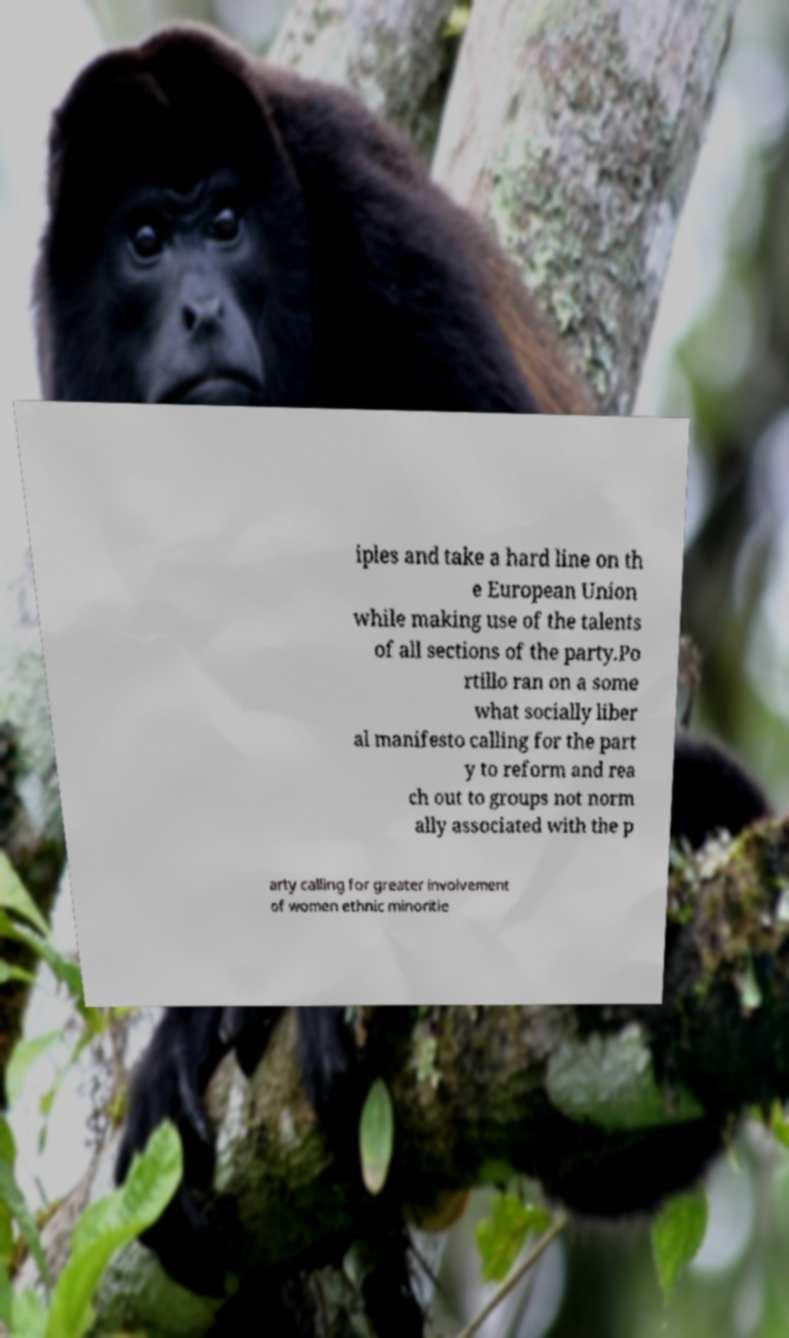Could you assist in decoding the text presented in this image and type it out clearly? iples and take a hard line on th e European Union while making use of the talents of all sections of the party.Po rtillo ran on a some what socially liber al manifesto calling for the part y to reform and rea ch out to groups not norm ally associated with the p arty calling for greater involvement of women ethnic minoritie 